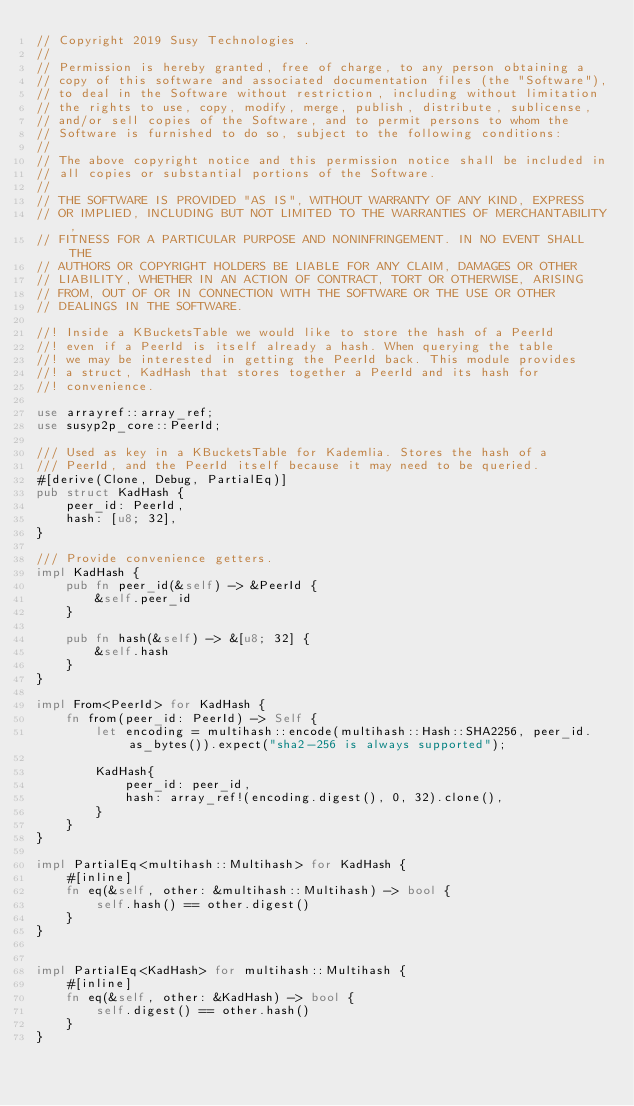Convert code to text. <code><loc_0><loc_0><loc_500><loc_500><_Rust_>// Copyright 2019 Susy Technologies .
//
// Permission is hereby granted, free of charge, to any person obtaining a
// copy of this software and associated documentation files (the "Software"),
// to deal in the Software without restriction, including without limitation
// the rights to use, copy, modify, merge, publish, distribute, sublicense,
// and/or sell copies of the Software, and to permit persons to whom the
// Software is furnished to do so, subject to the following conditions:
//
// The above copyright notice and this permission notice shall be included in
// all copies or substantial portions of the Software.
//
// THE SOFTWARE IS PROVIDED "AS IS", WITHOUT WARRANTY OF ANY KIND, EXPRESS
// OR IMPLIED, INCLUDING BUT NOT LIMITED TO THE WARRANTIES OF MERCHANTABILITY,
// FITNESS FOR A PARTICULAR PURPOSE AND NONINFRINGEMENT. IN NO EVENT SHALL THE
// AUTHORS OR COPYRIGHT HOLDERS BE LIABLE FOR ANY CLAIM, DAMAGES OR OTHER
// LIABILITY, WHETHER IN AN ACTION OF CONTRACT, TORT OR OTHERWISE, ARISING
// FROM, OUT OF OR IN CONNECTION WITH THE SOFTWARE OR THE USE OR OTHER
// DEALINGS IN THE SOFTWARE.

//! Inside a KBucketsTable we would like to store the hash of a PeerId
//! even if a PeerId is itself already a hash. When querying the table
//! we may be interested in getting the PeerId back. This module provides
//! a struct, KadHash that stores together a PeerId and its hash for
//! convenience.

use arrayref::array_ref;
use susyp2p_core::PeerId;

/// Used as key in a KBucketsTable for Kademlia. Stores the hash of a
/// PeerId, and the PeerId itself because it may need to be queried.
#[derive(Clone, Debug, PartialEq)]
pub struct KadHash {
    peer_id: PeerId,
    hash: [u8; 32],
}

/// Provide convenience getters.
impl KadHash {
    pub fn peer_id(&self) -> &PeerId {
        &self.peer_id
    }

    pub fn hash(&self) -> &[u8; 32] {
        &self.hash
    }
}

impl From<PeerId> for KadHash {
    fn from(peer_id: PeerId) -> Self {
        let encoding = multihash::encode(multihash::Hash::SHA2256, peer_id.as_bytes()).expect("sha2-256 is always supported");

        KadHash{
            peer_id: peer_id,
            hash: array_ref!(encoding.digest(), 0, 32).clone(),
        }
    }
}

impl PartialEq<multihash::Multihash> for KadHash {
    #[inline]
    fn eq(&self, other: &multihash::Multihash) -> bool {
        self.hash() == other.digest()
    }
}


impl PartialEq<KadHash> for multihash::Multihash {
    #[inline]
    fn eq(&self, other: &KadHash) -> bool {
        self.digest() == other.hash()
    }
}
</code> 